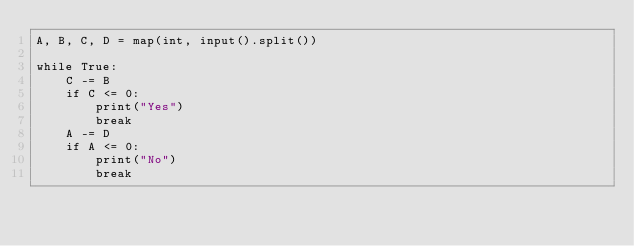<code> <loc_0><loc_0><loc_500><loc_500><_Python_>A, B, C, D = map(int, input().split())

while True:
    C -= B
    if C <= 0:
        print("Yes")
        break
    A -= D
    if A <= 0:
        print("No")
        break</code> 